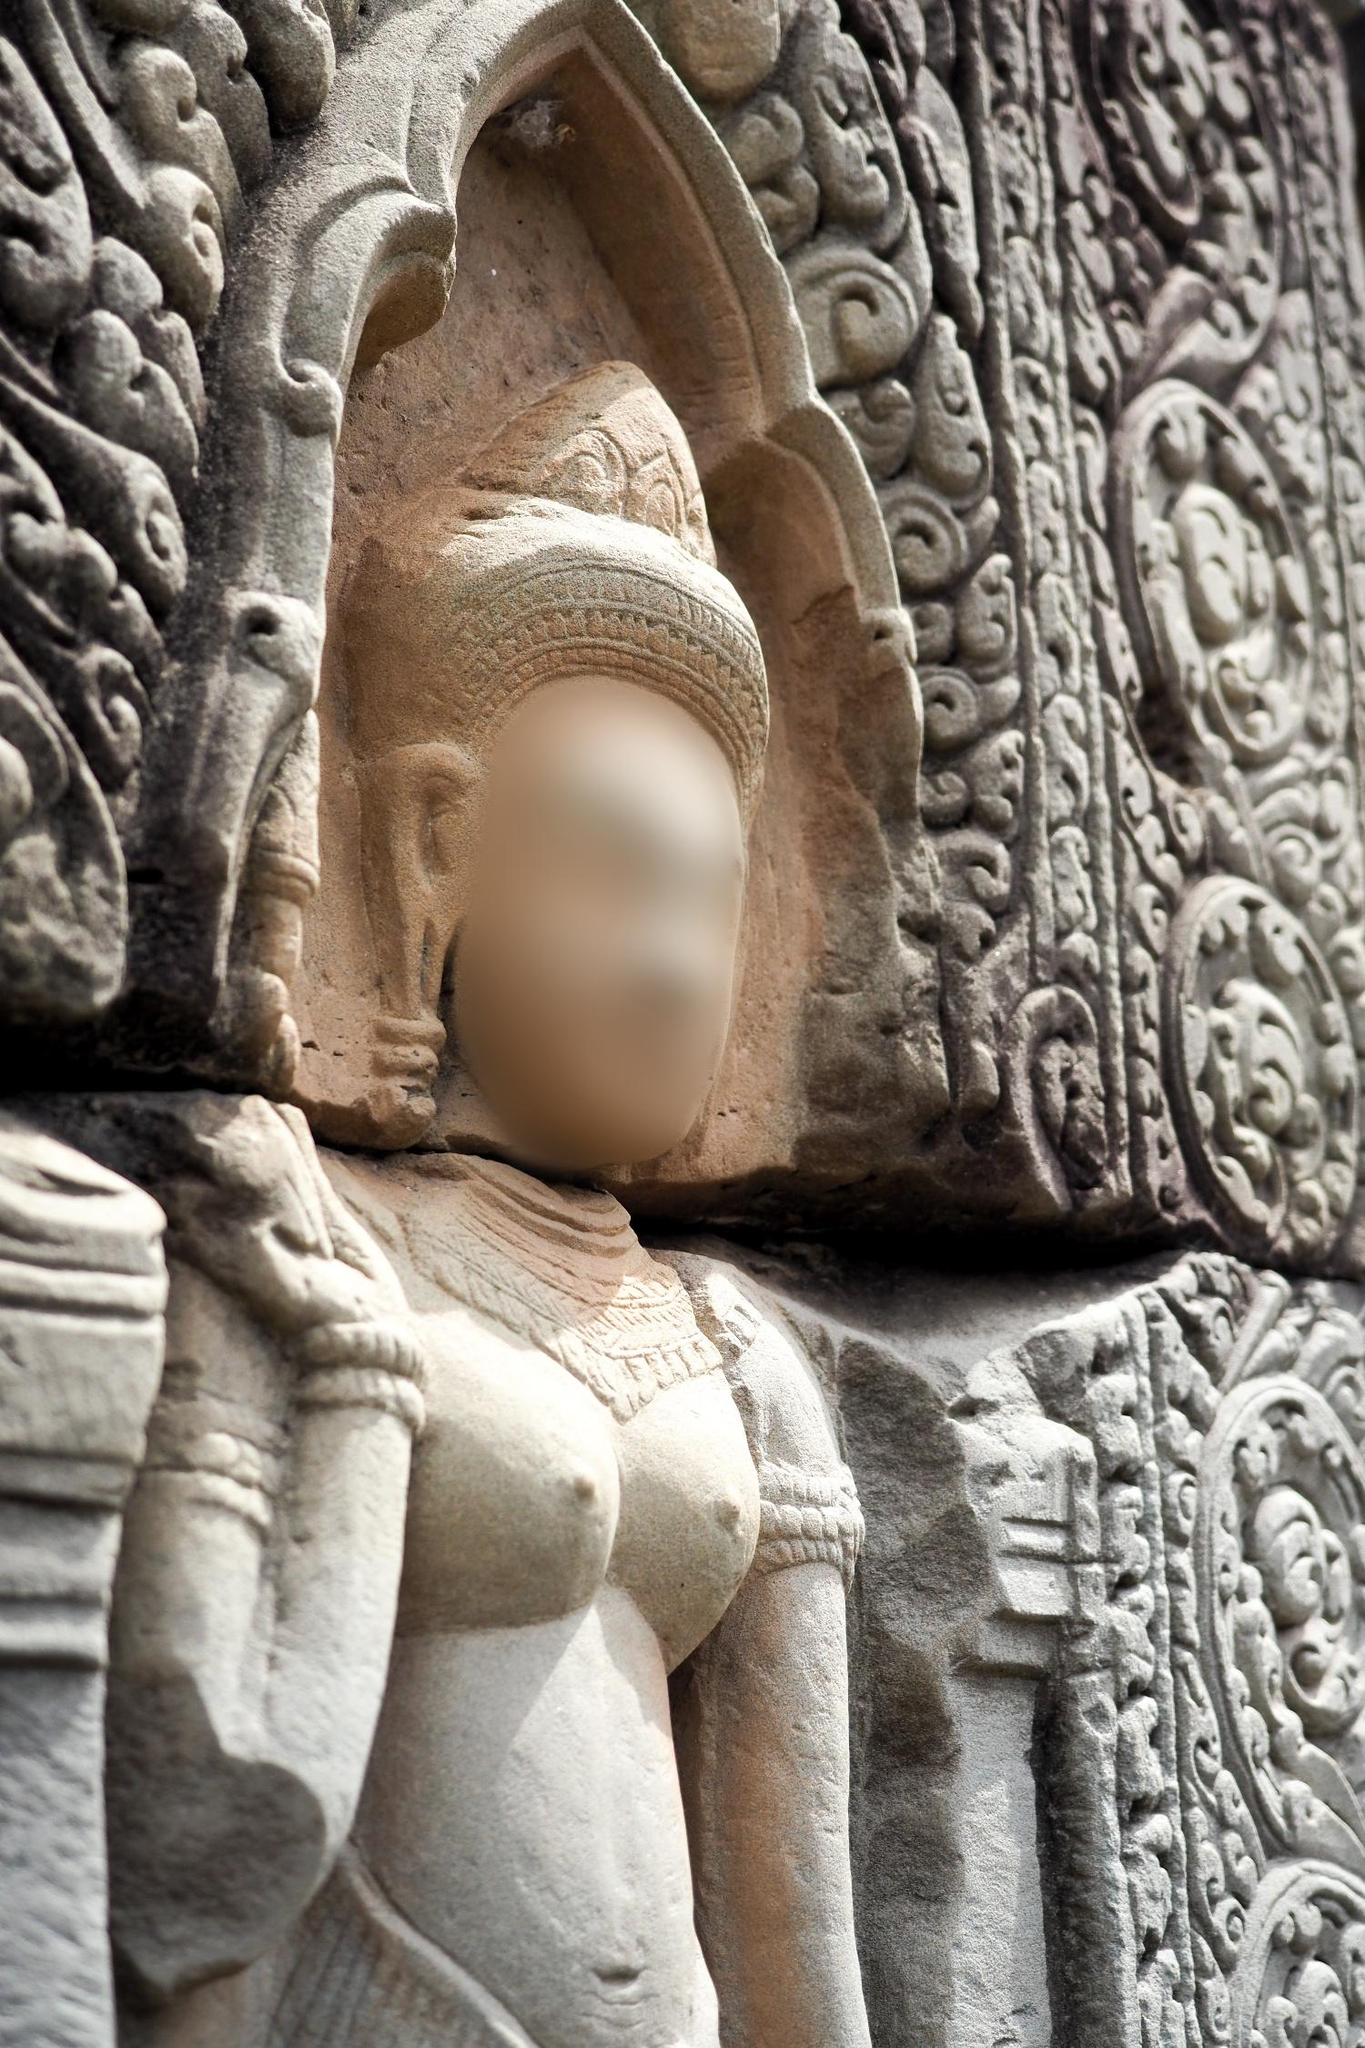What do you see happening in this image? The image presents a detailed view of an intricately carved stone statue set within a likely ancient or religious site. The statue features a blurred face, adding a sense of timeless enigma. The figure is adorned with a richly detailed headdress, indicative of a person of significant status or divinity. The surrounding stone carvings exhibit remarkable craftsmanship and artistic expression, suggesting that this sculpture is part of a larger, historically significant structure. The stone medium gives it an aged, eternal quality, hinting at centuries of history and cultural significance embedded in its existence. The identifier 'sa_11068' does not yield any additional specific information about this location in current databases, leaving the statue's tales locked within its stony visage. This monumental artwork stands as a sentinel of history, silently narrating the mysteries and legends of ancient times. 